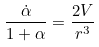Convert formula to latex. <formula><loc_0><loc_0><loc_500><loc_500>\frac { \dot { \alpha } } { 1 + \alpha } = \frac { 2 V } { r ^ { 3 } }</formula> 